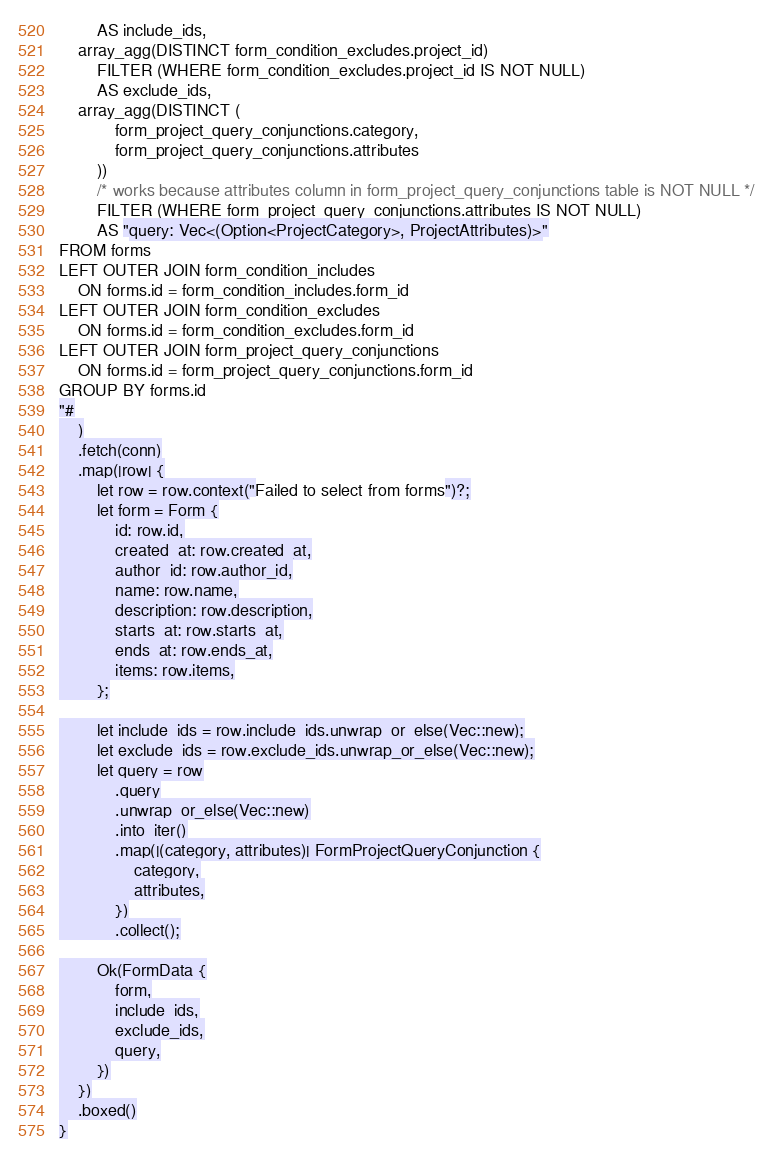Convert code to text. <code><loc_0><loc_0><loc_500><loc_500><_Rust_>        AS include_ids,
    array_agg(DISTINCT form_condition_excludes.project_id)
        FILTER (WHERE form_condition_excludes.project_id IS NOT NULL)
        AS exclude_ids,
    array_agg(DISTINCT (
            form_project_query_conjunctions.category,
            form_project_query_conjunctions.attributes
        ))
        /* works because attributes column in form_project_query_conjunctions table is NOT NULL */
        FILTER (WHERE form_project_query_conjunctions.attributes IS NOT NULL)
        AS "query: Vec<(Option<ProjectCategory>, ProjectAttributes)>"
FROM forms
LEFT OUTER JOIN form_condition_includes
    ON forms.id = form_condition_includes.form_id
LEFT OUTER JOIN form_condition_excludes
    ON forms.id = form_condition_excludes.form_id
LEFT OUTER JOIN form_project_query_conjunctions
    ON forms.id = form_project_query_conjunctions.form_id
GROUP BY forms.id
"#
    )
    .fetch(conn)
    .map(|row| {
        let row = row.context("Failed to select from forms")?;
        let form = Form {
            id: row.id,
            created_at: row.created_at,
            author_id: row.author_id,
            name: row.name,
            description: row.description,
            starts_at: row.starts_at,
            ends_at: row.ends_at,
            items: row.items,
        };

        let include_ids = row.include_ids.unwrap_or_else(Vec::new);
        let exclude_ids = row.exclude_ids.unwrap_or_else(Vec::new);
        let query = row
            .query
            .unwrap_or_else(Vec::new)
            .into_iter()
            .map(|(category, attributes)| FormProjectQueryConjunction {
                category,
                attributes,
            })
            .collect();

        Ok(FormData {
            form,
            include_ids,
            exclude_ids,
            query,
        })
    })
    .boxed()
}
</code> 